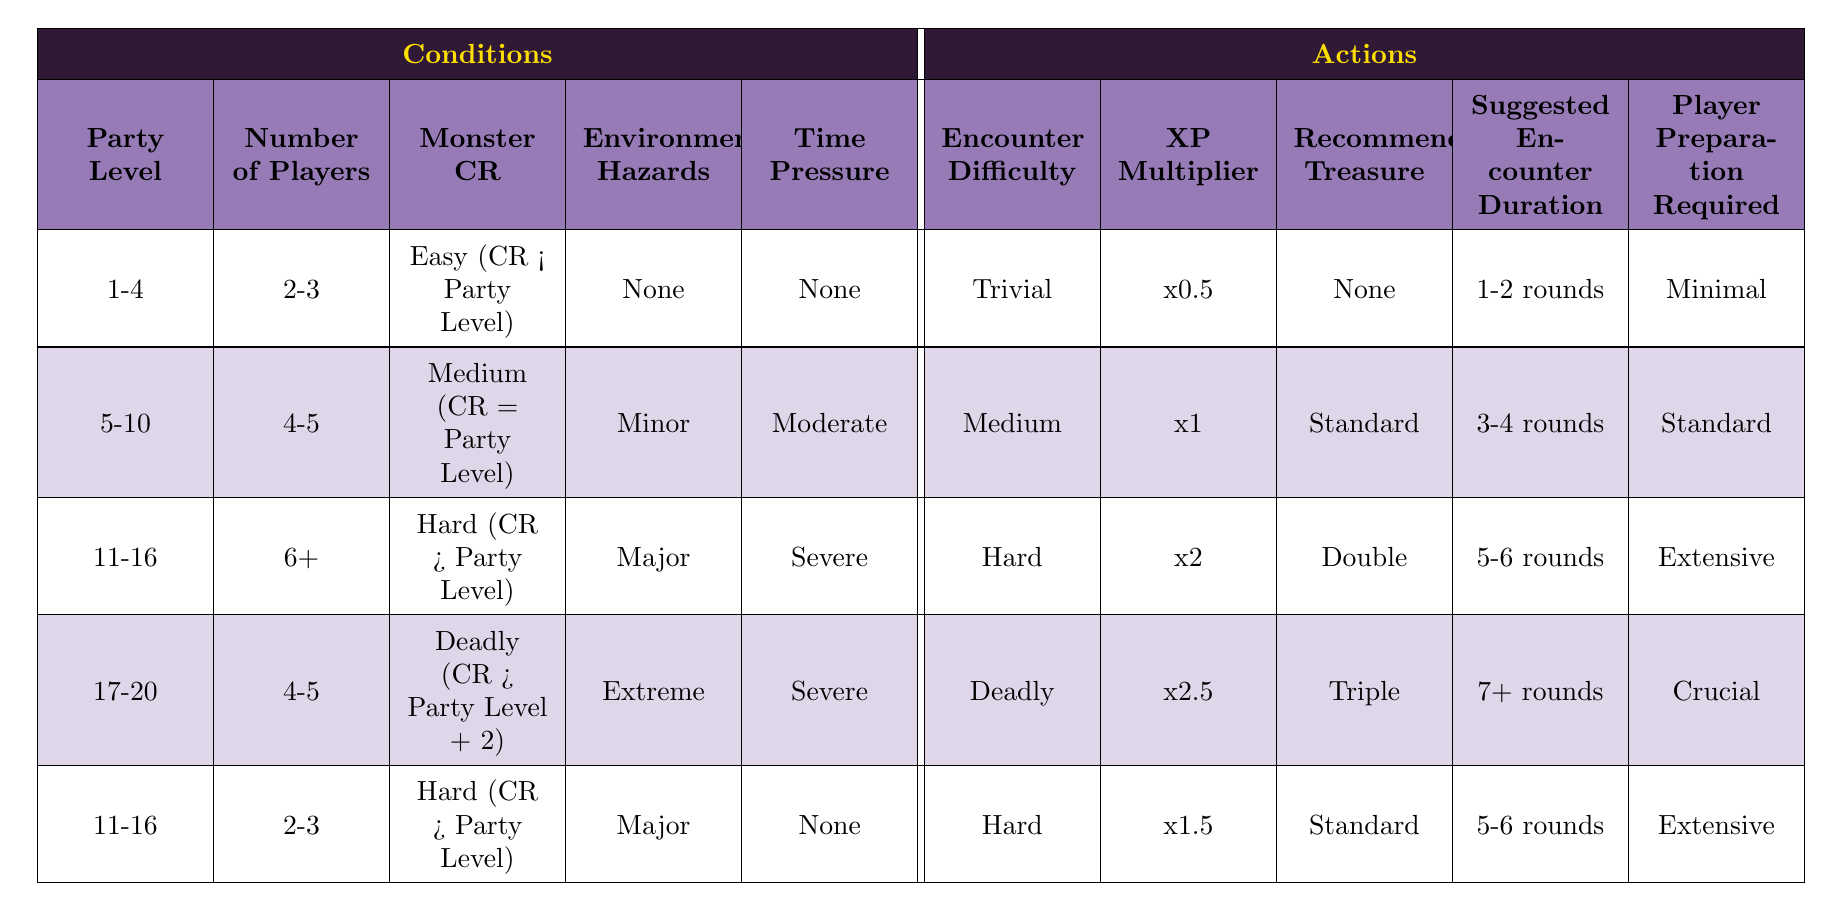What encounter difficulty can a party of level 1-4 expect with 2-3 players and no environmental hazards? According to the table, for a party level of 1-4 with 2-3 players, and no environmental hazards, the encounter difficulty is categorized as Trivial.
Answer: Trivial What is the suggested encounter duration when the monster's challenge rating is Hard for a level 11-16 party with 6 or more players and major environmental hazards? The table shows that for a level 11-16 party with 6+ players, a Hard monster, and major environmental hazards, the suggested encounter duration is between 5-6 rounds.
Answer: 5-6 rounds Is it true that a party of level 17-20 facing a Deadly encounter will require crucial player preparation? Yes, based on the table, a party of level 17-20 facing a Deadly encounter does indeed require crucial player preparation, as stated in the relevant row.
Answer: Yes If a party of level 5-10 with 4-5 players faces a Medium challenge monster and moderate time pressure, what is the XP multiplier? The table indicates that for a party of level 5-10 with 4-5 players facing a Medium challenge monster under moderate time pressure, the XP multiplier is x1.
Answer: x1 For a party of level 11-16 with 2-3 players encountering a Hard monster with major hazards and no time pressure, what is the level of encounter difficulty? The table indicates that for a level 11-16 party with 2-3 players facing a Hard monster with major hazards and no time pressure, the encounter difficulty is classified as Hard.
Answer: Hard What is the difference in recommended treasure between a Trivial encounter and a Deadly encounter? The recommended treasure for a Trivial encounter is None, while the recommended treasure for a Deadly encounter is Triple. The difference is therefore from None to Triple, which indicates a significant increase.
Answer: From None to Triple What is the XP multiplier if the party level is 11-16, the number of players is 6 or more, the monster CR is Deadly, there are major environmental hazards, and time pressure is severe? Based on the table, there are no conditions that match this scenario for the XP multiplier. However, for 11-16 with 6+ players facing Hard, the multiplier is x2. Therefore, if we consider the Deadly aspect, it's ideal to refer back to the monster's challenge rating and conclude that the row does not provide a direct answer.
Answer: Not specified 